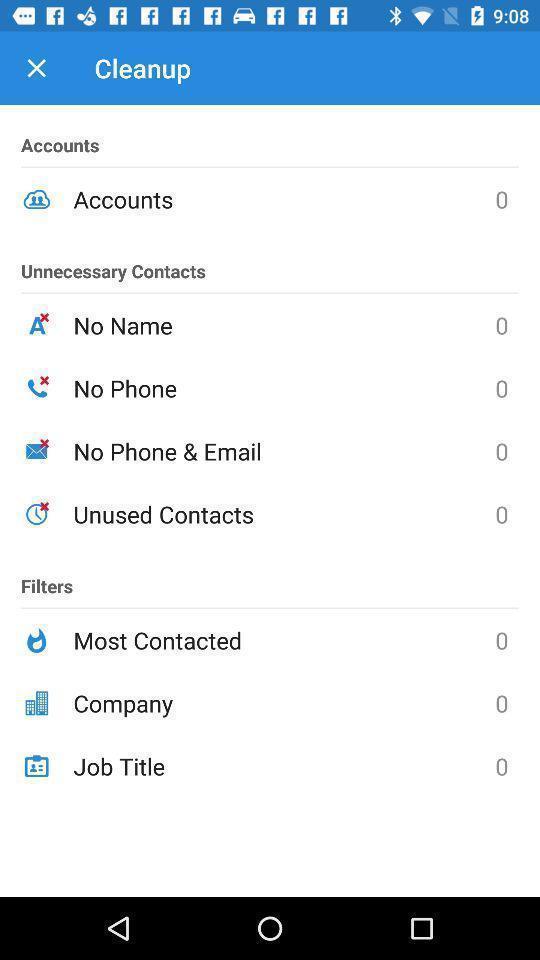What is the overall content of this screenshot? Screen display cleanup page. 